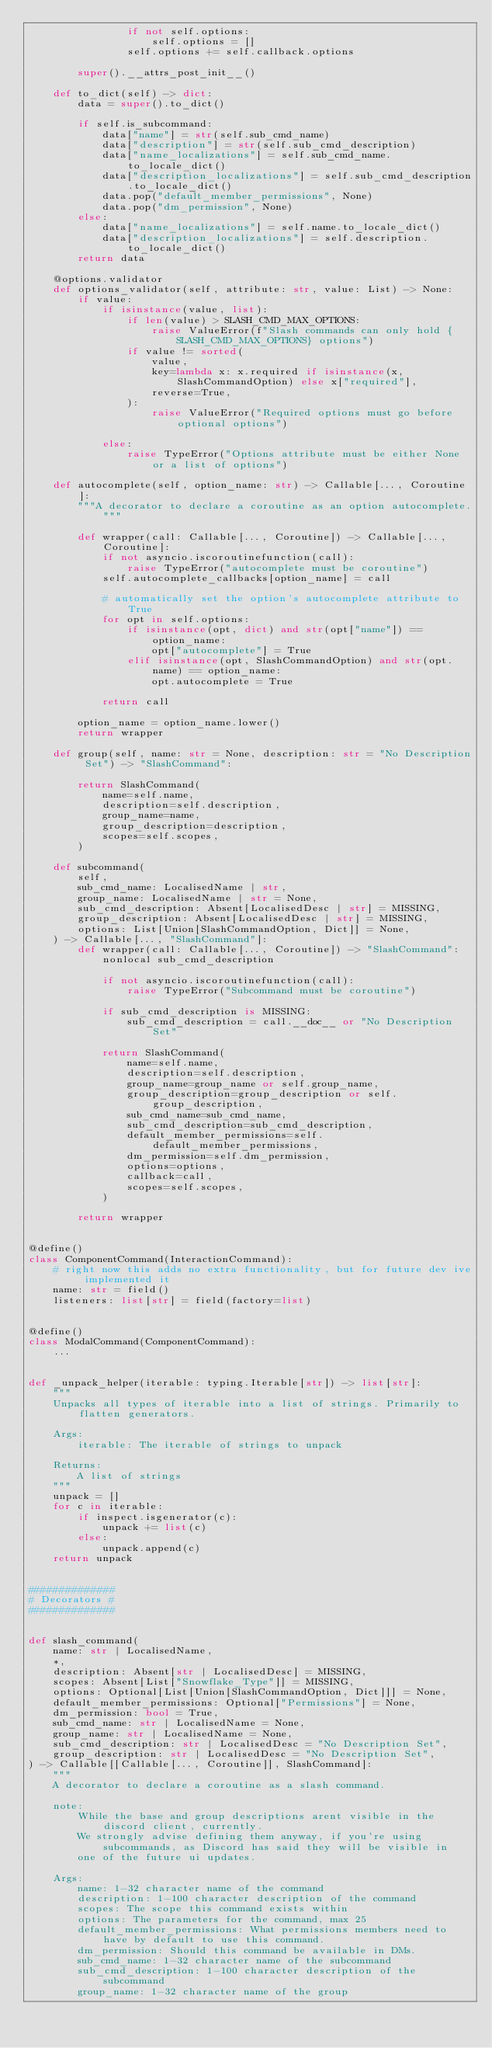Convert code to text. <code><loc_0><loc_0><loc_500><loc_500><_Python_>                if not self.options:
                    self.options = []
                self.options += self.callback.options

        super().__attrs_post_init__()

    def to_dict(self) -> dict:
        data = super().to_dict()

        if self.is_subcommand:
            data["name"] = str(self.sub_cmd_name)
            data["description"] = str(self.sub_cmd_description)
            data["name_localizations"] = self.sub_cmd_name.to_locale_dict()
            data["description_localizations"] = self.sub_cmd_description.to_locale_dict()
            data.pop("default_member_permissions", None)
            data.pop("dm_permission", None)
        else:
            data["name_localizations"] = self.name.to_locale_dict()
            data["description_localizations"] = self.description.to_locale_dict()
        return data

    @options.validator
    def options_validator(self, attribute: str, value: List) -> None:
        if value:
            if isinstance(value, list):
                if len(value) > SLASH_CMD_MAX_OPTIONS:
                    raise ValueError(f"Slash commands can only hold {SLASH_CMD_MAX_OPTIONS} options")
                if value != sorted(
                    value,
                    key=lambda x: x.required if isinstance(x, SlashCommandOption) else x["required"],
                    reverse=True,
                ):
                    raise ValueError("Required options must go before optional options")

            else:
                raise TypeError("Options attribute must be either None or a list of options")

    def autocomplete(self, option_name: str) -> Callable[..., Coroutine]:
        """A decorator to declare a coroutine as an option autocomplete."""

        def wrapper(call: Callable[..., Coroutine]) -> Callable[..., Coroutine]:
            if not asyncio.iscoroutinefunction(call):
                raise TypeError("autocomplete must be coroutine")
            self.autocomplete_callbacks[option_name] = call

            # automatically set the option's autocomplete attribute to True
            for opt in self.options:
                if isinstance(opt, dict) and str(opt["name"]) == option_name:
                    opt["autocomplete"] = True
                elif isinstance(opt, SlashCommandOption) and str(opt.name) == option_name:
                    opt.autocomplete = True

            return call

        option_name = option_name.lower()
        return wrapper

    def group(self, name: str = None, description: str = "No Description Set") -> "SlashCommand":

        return SlashCommand(
            name=self.name,
            description=self.description,
            group_name=name,
            group_description=description,
            scopes=self.scopes,
        )

    def subcommand(
        self,
        sub_cmd_name: LocalisedName | str,
        group_name: LocalisedName | str = None,
        sub_cmd_description: Absent[LocalisedDesc | str] = MISSING,
        group_description: Absent[LocalisedDesc | str] = MISSING,
        options: List[Union[SlashCommandOption, Dict]] = None,
    ) -> Callable[..., "SlashCommand"]:
        def wrapper(call: Callable[..., Coroutine]) -> "SlashCommand":
            nonlocal sub_cmd_description

            if not asyncio.iscoroutinefunction(call):
                raise TypeError("Subcommand must be coroutine")

            if sub_cmd_description is MISSING:
                sub_cmd_description = call.__doc__ or "No Description Set"

            return SlashCommand(
                name=self.name,
                description=self.description,
                group_name=group_name or self.group_name,
                group_description=group_description or self.group_description,
                sub_cmd_name=sub_cmd_name,
                sub_cmd_description=sub_cmd_description,
                default_member_permissions=self.default_member_permissions,
                dm_permission=self.dm_permission,
                options=options,
                callback=call,
                scopes=self.scopes,
            )

        return wrapper


@define()
class ComponentCommand(InteractionCommand):
    # right now this adds no extra functionality, but for future dev ive implemented it
    name: str = field()
    listeners: list[str] = field(factory=list)


@define()
class ModalCommand(ComponentCommand):
    ...


def _unpack_helper(iterable: typing.Iterable[str]) -> list[str]:
    """
    Unpacks all types of iterable into a list of strings. Primarily to flatten generators.

    Args:
        iterable: The iterable of strings to unpack

    Returns:
        A list of strings
    """
    unpack = []
    for c in iterable:
        if inspect.isgenerator(c):
            unpack += list(c)
        else:
            unpack.append(c)
    return unpack


##############
# Decorators #
##############


def slash_command(
    name: str | LocalisedName,
    *,
    description: Absent[str | LocalisedDesc] = MISSING,
    scopes: Absent[List["Snowflake_Type"]] = MISSING,
    options: Optional[List[Union[SlashCommandOption, Dict]]] = None,
    default_member_permissions: Optional["Permissions"] = None,
    dm_permission: bool = True,
    sub_cmd_name: str | LocalisedName = None,
    group_name: str | LocalisedName = None,
    sub_cmd_description: str | LocalisedDesc = "No Description Set",
    group_description: str | LocalisedDesc = "No Description Set",
) -> Callable[[Callable[..., Coroutine]], SlashCommand]:
    """
    A decorator to declare a coroutine as a slash command.

    note:
        While the base and group descriptions arent visible in the discord client, currently.
        We strongly advise defining them anyway, if you're using subcommands, as Discord has said they will be visible in
        one of the future ui updates.

    Args:
        name: 1-32 character name of the command
        description: 1-100 character description of the command
        scopes: The scope this command exists within
        options: The parameters for the command, max 25
        default_member_permissions: What permissions members need to have by default to use this command.
        dm_permission: Should this command be available in DMs.
        sub_cmd_name: 1-32 character name of the subcommand
        sub_cmd_description: 1-100 character description of the subcommand
        group_name: 1-32 character name of the group</code> 